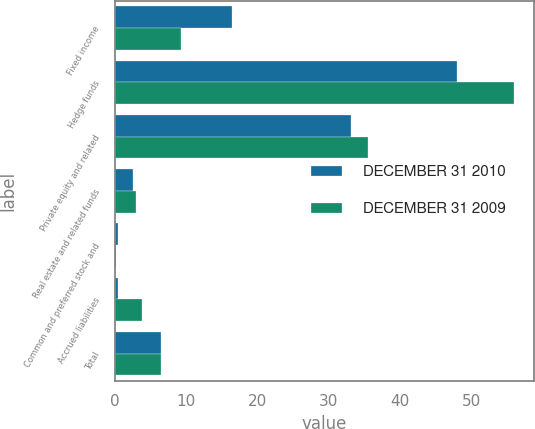<chart> <loc_0><loc_0><loc_500><loc_500><stacked_bar_chart><ecel><fcel>Fixed income<fcel>Hedge funds<fcel>Private equity and related<fcel>Real estate and related funds<fcel>Common and preferred stock and<fcel>Accrued liabilities<fcel>Total<nl><fcel>DECEMBER 31 2010<fcel>16.4<fcel>48<fcel>33.1<fcel>2.5<fcel>0.4<fcel>0.4<fcel>6.5<nl><fcel>DECEMBER 31 2009<fcel>9.2<fcel>55.9<fcel>35.5<fcel>3<fcel>0.1<fcel>3.8<fcel>6.5<nl></chart> 